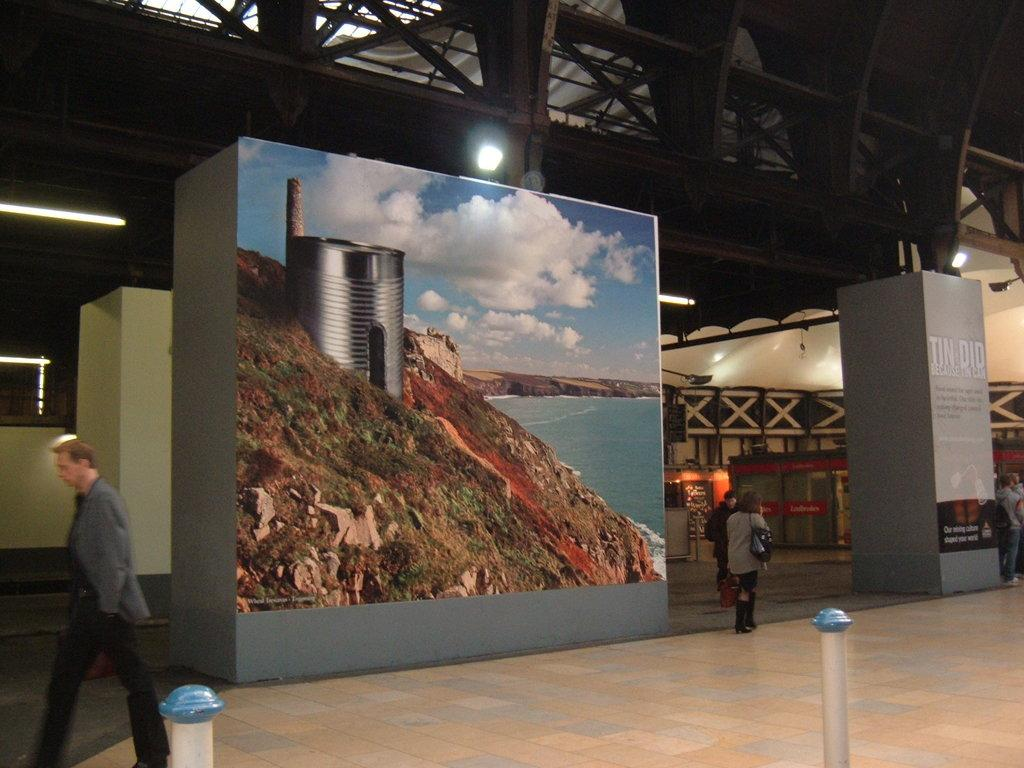Who or what can be seen in the image? There are people in the image. What is on the wall in the image? There are boards with images on the wall. What type of illumination is present in the image? There are lights in the image. What architectural features can be observed in the image? There are poles and pillars in the image. What part of a building is visible in the image? There is a roof visible in the image. What type of ice is being served by the expert in the image? There is no ice or expert present in the image. 